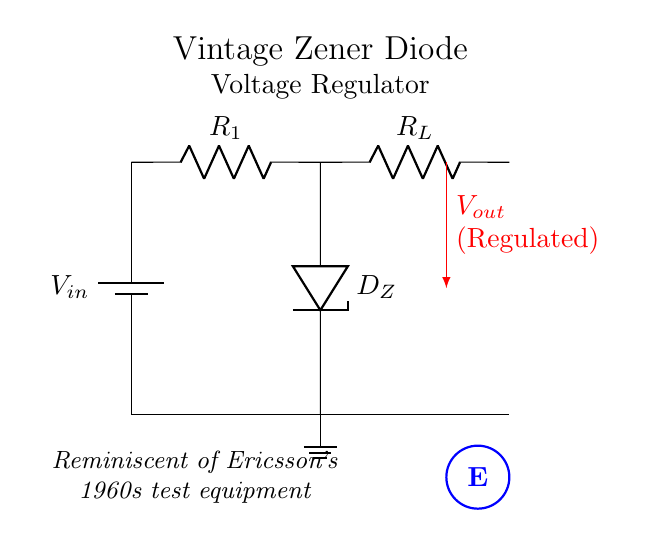What type of diode is used in this circuit? The circuit diagram includes a Zener diode, which is specifically noted with the label D_Z. This type of diode is used for voltage regulation in the diagram.
Answer: Zener diode What is the purpose of the resistor R1? Resistor R1 acts as a current limiting device ensuring that an appropriate current flows through the Zener diode to maintain a stable output voltage. It is crucial for the proper operation of the voltage regulator.
Answer: Current limiting What is the output voltage of the regulator represented by in the circuit? The output voltage is indicated by the notation V_out, which is labeled in red with an arrow pointing downward. This shows it is regulated and derives from the Zener diode's breakdown voltage.
Answer: V_out How is the Zener diode connected in the circuit? The Zener diode is connected in a reverse-biased configuration, meaning that it allows current to flow in the reverse direction once the applied voltage exceeds its breakdown voltage, thus stabilizing the output voltage from fluctuations.
Answer: Reverse-biased What distinguishes this voltage regulator as "vintage"? The term "vintage" is explicitly mentioned in the title of the circuit as well as the nostalgic note beneath it, suggesting it employs techniques and components typical of the 1960s era, including the use of Zener diodes in voltage regulation.
Answer: Vintage components What happens to the output voltage if the input voltage increases significantly? If the input voltage significantly increases, the Zener diode will continue to regulate the output voltage, provided that the current through it does not exceed its maximum rating. The output voltage remains stable, reflecting the Zener breakdown voltage.
Answer: Stable output 